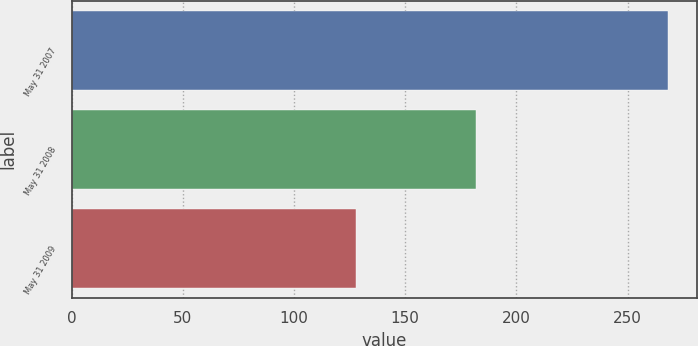<chart> <loc_0><loc_0><loc_500><loc_500><bar_chart><fcel>May 31 2007<fcel>May 31 2008<fcel>May 31 2009<nl><fcel>268<fcel>182<fcel>128<nl></chart> 